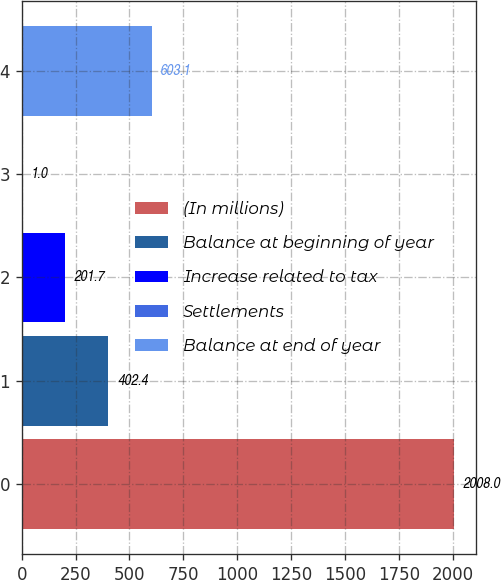Convert chart to OTSL. <chart><loc_0><loc_0><loc_500><loc_500><bar_chart><fcel>(In millions)<fcel>Balance at beginning of year<fcel>Increase related to tax<fcel>Settlements<fcel>Balance at end of year<nl><fcel>2008<fcel>402.4<fcel>201.7<fcel>1<fcel>603.1<nl></chart> 